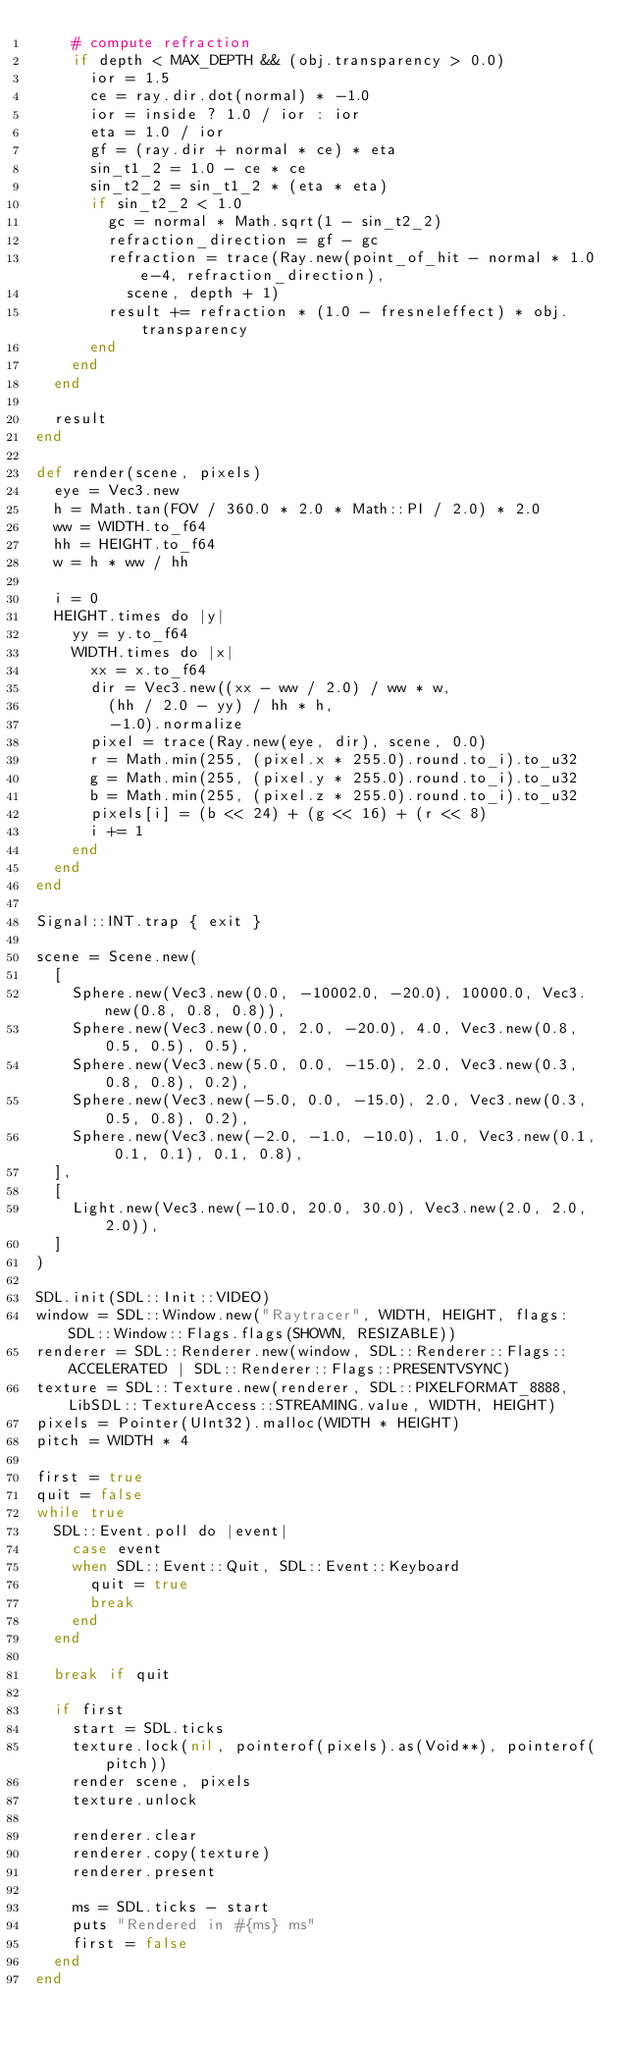<code> <loc_0><loc_0><loc_500><loc_500><_Crystal_>    # compute refraction
    if depth < MAX_DEPTH && (obj.transparency > 0.0)
      ior = 1.5
      ce = ray.dir.dot(normal) * -1.0
      ior = inside ? 1.0 / ior : ior
      eta = 1.0 / ior
      gf = (ray.dir + normal * ce) * eta
      sin_t1_2 = 1.0 - ce * ce
      sin_t2_2 = sin_t1_2 * (eta * eta)
      if sin_t2_2 < 1.0
        gc = normal * Math.sqrt(1 - sin_t2_2)
        refraction_direction = gf - gc
        refraction = trace(Ray.new(point_of_hit - normal * 1.0e-4, refraction_direction),
          scene, depth + 1)
        result += refraction * (1.0 - fresneleffect) * obj.transparency
      end
    end
  end

  result
end

def render(scene, pixels)
  eye = Vec3.new
  h = Math.tan(FOV / 360.0 * 2.0 * Math::PI / 2.0) * 2.0
  ww = WIDTH.to_f64
  hh = HEIGHT.to_f64
  w = h * ww / hh

  i = 0
  HEIGHT.times do |y|
    yy = y.to_f64
    WIDTH.times do |x|
      xx = x.to_f64
      dir = Vec3.new((xx - ww / 2.0) / ww * w,
        (hh / 2.0 - yy) / hh * h,
        -1.0).normalize
      pixel = trace(Ray.new(eye, dir), scene, 0.0)
      r = Math.min(255, (pixel.x * 255.0).round.to_i).to_u32
      g = Math.min(255, (pixel.y * 255.0).round.to_i).to_u32
      b = Math.min(255, (pixel.z * 255.0).round.to_i).to_u32
      pixels[i] = (b << 24) + (g << 16) + (r << 8)
      i += 1
    end
  end
end

Signal::INT.trap { exit }

scene = Scene.new(
  [
    Sphere.new(Vec3.new(0.0, -10002.0, -20.0), 10000.0, Vec3.new(0.8, 0.8, 0.8)),
    Sphere.new(Vec3.new(0.0, 2.0, -20.0), 4.0, Vec3.new(0.8, 0.5, 0.5), 0.5),
    Sphere.new(Vec3.new(5.0, 0.0, -15.0), 2.0, Vec3.new(0.3, 0.8, 0.8), 0.2),
    Sphere.new(Vec3.new(-5.0, 0.0, -15.0), 2.0, Vec3.new(0.3, 0.5, 0.8), 0.2),
    Sphere.new(Vec3.new(-2.0, -1.0, -10.0), 1.0, Vec3.new(0.1, 0.1, 0.1), 0.1, 0.8),
  ],
  [
    Light.new(Vec3.new(-10.0, 20.0, 30.0), Vec3.new(2.0, 2.0, 2.0)),
  ]
)

SDL.init(SDL::Init::VIDEO)
window = SDL::Window.new("Raytracer", WIDTH, HEIGHT, flags: SDL::Window::Flags.flags(SHOWN, RESIZABLE))
renderer = SDL::Renderer.new(window, SDL::Renderer::Flags::ACCELERATED | SDL::Renderer::Flags::PRESENTVSYNC)
texture = SDL::Texture.new(renderer, SDL::PIXELFORMAT_8888, LibSDL::TextureAccess::STREAMING.value, WIDTH, HEIGHT)
pixels = Pointer(UInt32).malloc(WIDTH * HEIGHT)
pitch = WIDTH * 4

first = true
quit = false
while true
  SDL::Event.poll do |event|
    case event
    when SDL::Event::Quit, SDL::Event::Keyboard
      quit = true
      break
    end
  end

  break if quit

  if first
    start = SDL.ticks
    texture.lock(nil, pointerof(pixels).as(Void**), pointerof(pitch))
    render scene, pixels
    texture.unlock

    renderer.clear
    renderer.copy(texture)
    renderer.present

    ms = SDL.ticks - start
    puts "Rendered in #{ms} ms"
    first = false
  end
end
</code> 